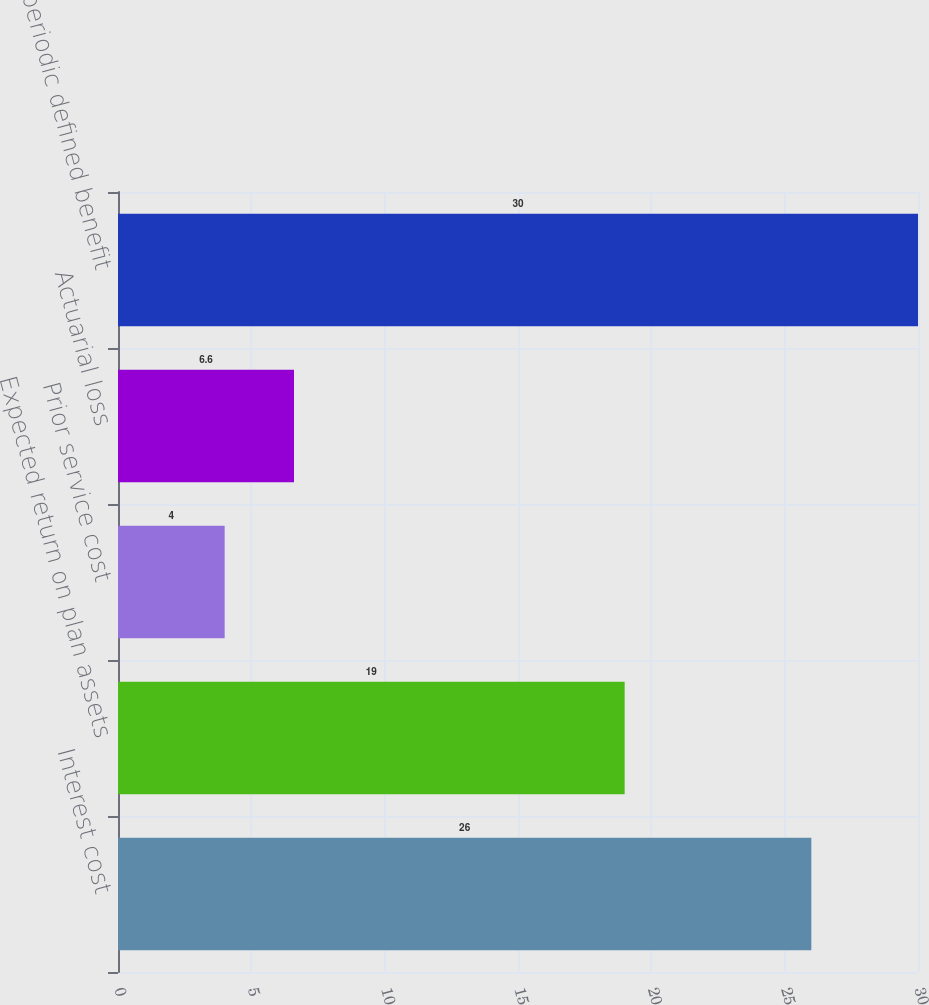<chart> <loc_0><loc_0><loc_500><loc_500><bar_chart><fcel>Interest cost<fcel>Expected return on plan assets<fcel>Prior service cost<fcel>Actuarial loss<fcel>Net periodic defined benefit<nl><fcel>26<fcel>19<fcel>4<fcel>6.6<fcel>30<nl></chart> 